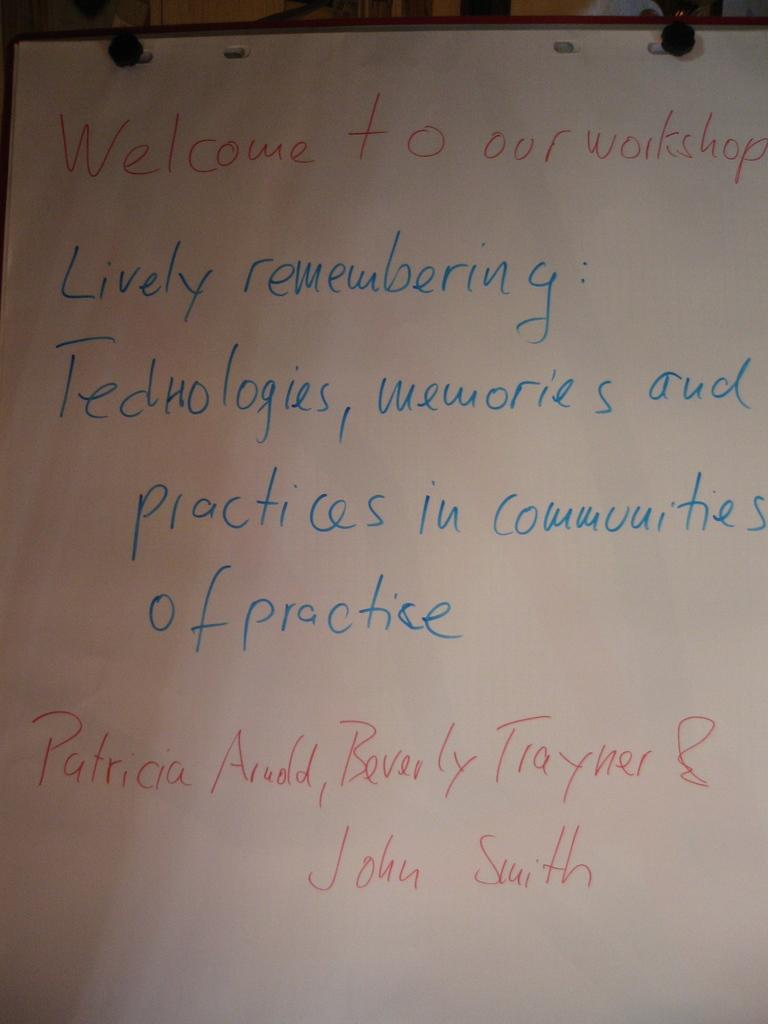<image>
Summarize the visual content of the image. A welcome message to a workshop about lively remembering. 